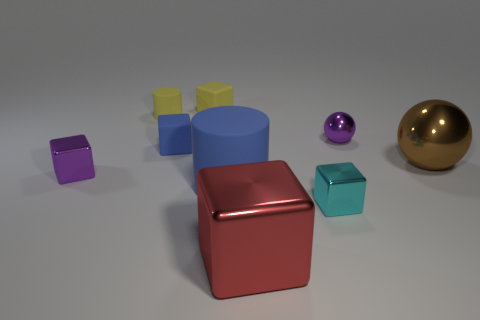There is a tiny matte cylinder; is its color the same as the tiny matte block that is behind the purple ball?
Provide a succinct answer. Yes. Are there any small objects that are to the right of the matte block that is behind the small purple metal object right of the red block?
Give a very brief answer. Yes. Is the number of purple blocks that are on the right side of the big matte cylinder less than the number of small purple matte balls?
Your response must be concise. No. What number of other things are the same shape as the cyan object?
Provide a succinct answer. 4. How many things are either large objects that are behind the blue cylinder or blocks that are on the right side of the purple cube?
Your answer should be compact. 5. There is a cube that is to the left of the yellow matte cube and right of the yellow cylinder; what is its size?
Your answer should be compact. Small. There is a purple metallic thing that is behind the tiny blue rubber object; is it the same shape as the tiny cyan shiny thing?
Offer a very short reply. No. How big is the blue object that is right of the cube that is behind the purple metallic thing on the right side of the cyan object?
Ensure brevity in your answer.  Large. What size is the metallic block that is the same color as the tiny sphere?
Give a very brief answer. Small. How many things are either purple spheres or small cyan shiny blocks?
Provide a short and direct response. 2. 